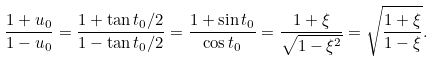<formula> <loc_0><loc_0><loc_500><loc_500>\frac { 1 + u _ { 0 } } { 1 - u _ { 0 } } = \frac { 1 + \tan t _ { 0 } / 2 } { 1 - \tan t _ { 0 } / 2 } = \frac { 1 + \sin t _ { 0 } } { \cos t _ { 0 } } = \frac { 1 + \xi } { \sqrt { 1 - \xi ^ { 2 } } } = \sqrt { \frac { 1 + \xi } { 1 - \xi } } .</formula> 